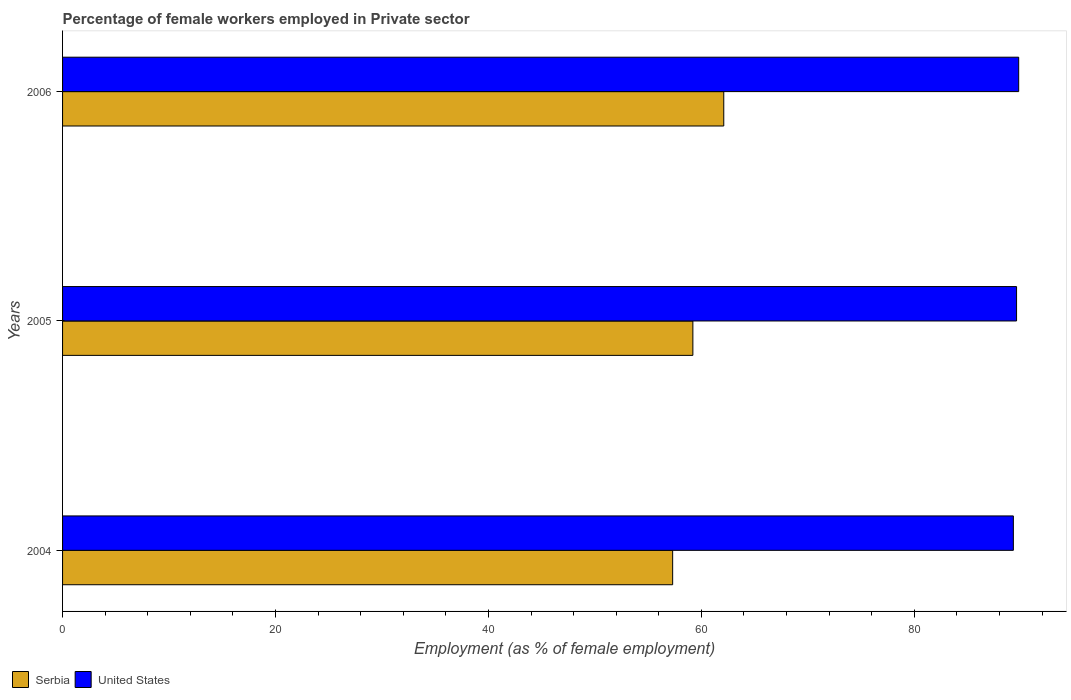Are the number of bars per tick equal to the number of legend labels?
Provide a succinct answer. Yes. Are the number of bars on each tick of the Y-axis equal?
Your answer should be very brief. Yes. How many bars are there on the 2nd tick from the top?
Provide a succinct answer. 2. What is the percentage of females employed in Private sector in United States in 2004?
Offer a very short reply. 89.3. Across all years, what is the maximum percentage of females employed in Private sector in Serbia?
Keep it short and to the point. 62.1. Across all years, what is the minimum percentage of females employed in Private sector in Serbia?
Provide a short and direct response. 57.3. What is the total percentage of females employed in Private sector in Serbia in the graph?
Your answer should be compact. 178.6. What is the difference between the percentage of females employed in Private sector in Serbia in 2004 and that in 2005?
Provide a short and direct response. -1.9. What is the difference between the percentage of females employed in Private sector in Serbia in 2004 and the percentage of females employed in Private sector in United States in 2006?
Make the answer very short. -32.5. What is the average percentage of females employed in Private sector in Serbia per year?
Ensure brevity in your answer.  59.53. In the year 2006, what is the difference between the percentage of females employed in Private sector in United States and percentage of females employed in Private sector in Serbia?
Keep it short and to the point. 27.7. In how many years, is the percentage of females employed in Private sector in Serbia greater than 44 %?
Ensure brevity in your answer.  3. What is the ratio of the percentage of females employed in Private sector in United States in 2005 to that in 2006?
Offer a terse response. 1. Is the percentage of females employed in Private sector in United States in 2005 less than that in 2006?
Make the answer very short. Yes. What is the difference between the highest and the second highest percentage of females employed in Private sector in Serbia?
Your answer should be compact. 2.9. What is the difference between the highest and the lowest percentage of females employed in Private sector in Serbia?
Your answer should be very brief. 4.8. In how many years, is the percentage of females employed in Private sector in Serbia greater than the average percentage of females employed in Private sector in Serbia taken over all years?
Your answer should be very brief. 1. What does the 1st bar from the top in 2004 represents?
Provide a succinct answer. United States. What does the 1st bar from the bottom in 2004 represents?
Provide a short and direct response. Serbia. How many years are there in the graph?
Keep it short and to the point. 3. Does the graph contain grids?
Your answer should be very brief. No. Where does the legend appear in the graph?
Your answer should be very brief. Bottom left. What is the title of the graph?
Give a very brief answer. Percentage of female workers employed in Private sector. What is the label or title of the X-axis?
Give a very brief answer. Employment (as % of female employment). What is the label or title of the Y-axis?
Give a very brief answer. Years. What is the Employment (as % of female employment) in Serbia in 2004?
Make the answer very short. 57.3. What is the Employment (as % of female employment) in United States in 2004?
Your answer should be very brief. 89.3. What is the Employment (as % of female employment) of Serbia in 2005?
Provide a short and direct response. 59.2. What is the Employment (as % of female employment) of United States in 2005?
Provide a succinct answer. 89.6. What is the Employment (as % of female employment) of Serbia in 2006?
Ensure brevity in your answer.  62.1. What is the Employment (as % of female employment) of United States in 2006?
Your answer should be compact. 89.8. Across all years, what is the maximum Employment (as % of female employment) of Serbia?
Provide a succinct answer. 62.1. Across all years, what is the maximum Employment (as % of female employment) of United States?
Give a very brief answer. 89.8. Across all years, what is the minimum Employment (as % of female employment) in Serbia?
Make the answer very short. 57.3. Across all years, what is the minimum Employment (as % of female employment) of United States?
Provide a short and direct response. 89.3. What is the total Employment (as % of female employment) of Serbia in the graph?
Offer a terse response. 178.6. What is the total Employment (as % of female employment) of United States in the graph?
Your answer should be compact. 268.7. What is the difference between the Employment (as % of female employment) of United States in 2004 and that in 2005?
Your answer should be very brief. -0.3. What is the difference between the Employment (as % of female employment) of United States in 2004 and that in 2006?
Your response must be concise. -0.5. What is the difference between the Employment (as % of female employment) of United States in 2005 and that in 2006?
Your response must be concise. -0.2. What is the difference between the Employment (as % of female employment) of Serbia in 2004 and the Employment (as % of female employment) of United States in 2005?
Ensure brevity in your answer.  -32.3. What is the difference between the Employment (as % of female employment) in Serbia in 2004 and the Employment (as % of female employment) in United States in 2006?
Offer a terse response. -32.5. What is the difference between the Employment (as % of female employment) in Serbia in 2005 and the Employment (as % of female employment) in United States in 2006?
Make the answer very short. -30.6. What is the average Employment (as % of female employment) of Serbia per year?
Your response must be concise. 59.53. What is the average Employment (as % of female employment) of United States per year?
Make the answer very short. 89.57. In the year 2004, what is the difference between the Employment (as % of female employment) in Serbia and Employment (as % of female employment) in United States?
Offer a terse response. -32. In the year 2005, what is the difference between the Employment (as % of female employment) of Serbia and Employment (as % of female employment) of United States?
Your response must be concise. -30.4. In the year 2006, what is the difference between the Employment (as % of female employment) in Serbia and Employment (as % of female employment) in United States?
Ensure brevity in your answer.  -27.7. What is the ratio of the Employment (as % of female employment) in Serbia in 2004 to that in 2005?
Ensure brevity in your answer.  0.97. What is the ratio of the Employment (as % of female employment) in United States in 2004 to that in 2005?
Ensure brevity in your answer.  1. What is the ratio of the Employment (as % of female employment) of Serbia in 2004 to that in 2006?
Your answer should be compact. 0.92. What is the ratio of the Employment (as % of female employment) of Serbia in 2005 to that in 2006?
Keep it short and to the point. 0.95. What is the ratio of the Employment (as % of female employment) in United States in 2005 to that in 2006?
Provide a succinct answer. 1. What is the difference between the highest and the second highest Employment (as % of female employment) of Serbia?
Provide a short and direct response. 2.9. What is the difference between the highest and the lowest Employment (as % of female employment) of Serbia?
Provide a succinct answer. 4.8. 